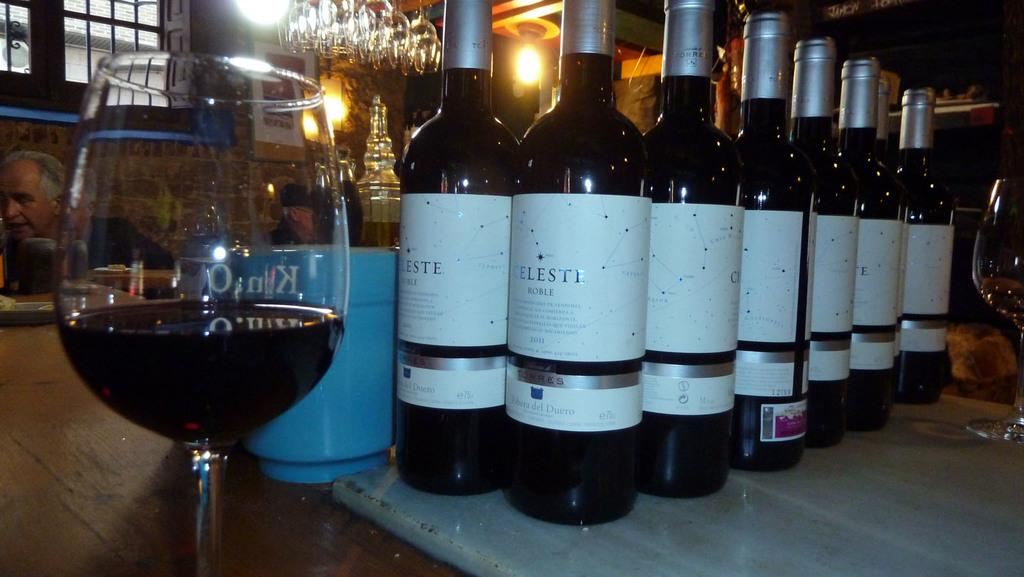<image>
Present a compact description of the photo's key features. Several bottles of Celesti red wine stand before a glass a quarter full of the same stuff. 